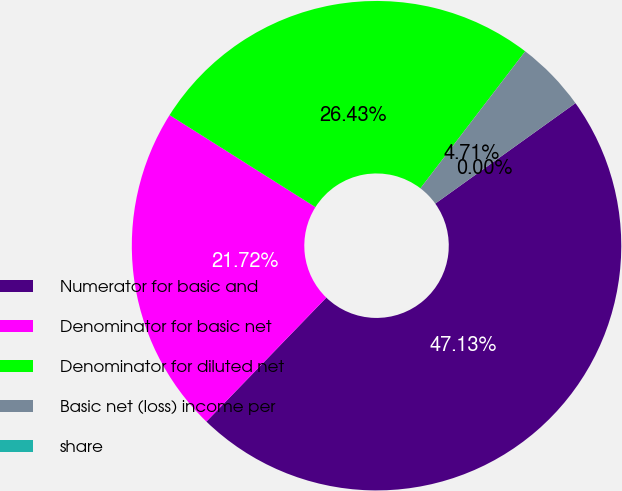Convert chart. <chart><loc_0><loc_0><loc_500><loc_500><pie_chart><fcel>Numerator for basic and<fcel>Denominator for basic net<fcel>Denominator for diluted net<fcel>Basic net (loss) income per<fcel>share<nl><fcel>47.13%<fcel>21.72%<fcel>26.43%<fcel>4.71%<fcel>0.0%<nl></chart> 